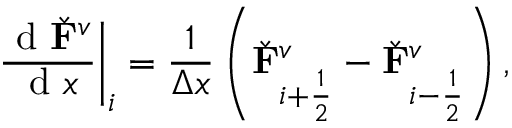Convert formula to latex. <formula><loc_0><loc_0><loc_500><loc_500>\frac { d \check { F } ^ { v } } { d x } \right | _ { i } = \frac { 1 } { \Delta x } \left ( \check { F } _ { i + \frac { 1 } { 2 } } ^ { v } - \check { F } _ { i - \frac { 1 } { 2 } } ^ { v } \right ) ,</formula> 